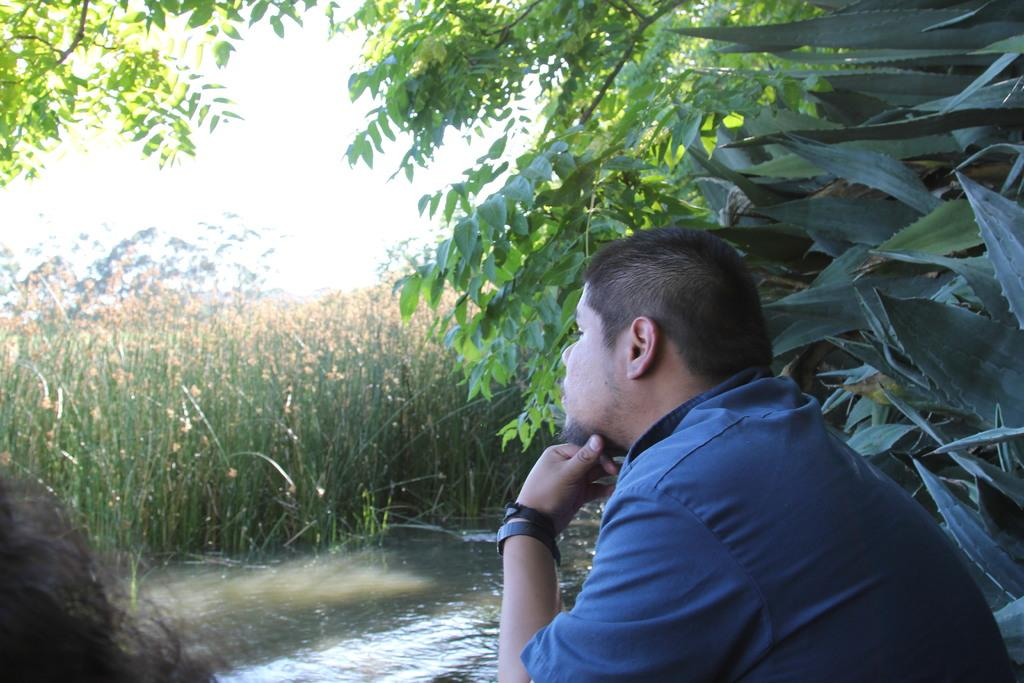How many people are in the image? There are two persons in the image. What is visible in the image besides the people? Water, plants, trees, and the sky are visible in the image. Can you describe the natural setting in the image? The image may have been taken near a lake, as there is water visible and trees in the background. What type of dress is the rabbit wearing in the image? There are no rabbits present in the image, and therefore no dress or any clothing can be observed. 